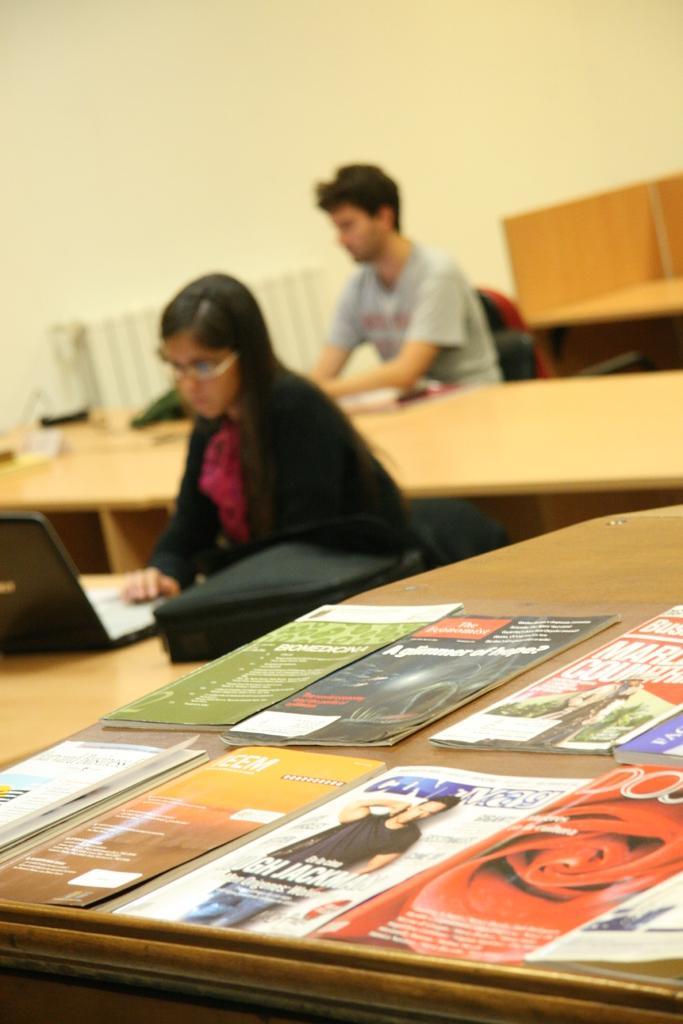Describe this image in one or two sentences. in this image, There are some tables which are in yellow color, And on that table there are some books, In the background there are some people sitting on the chairs, There is a wall which is in white color. 